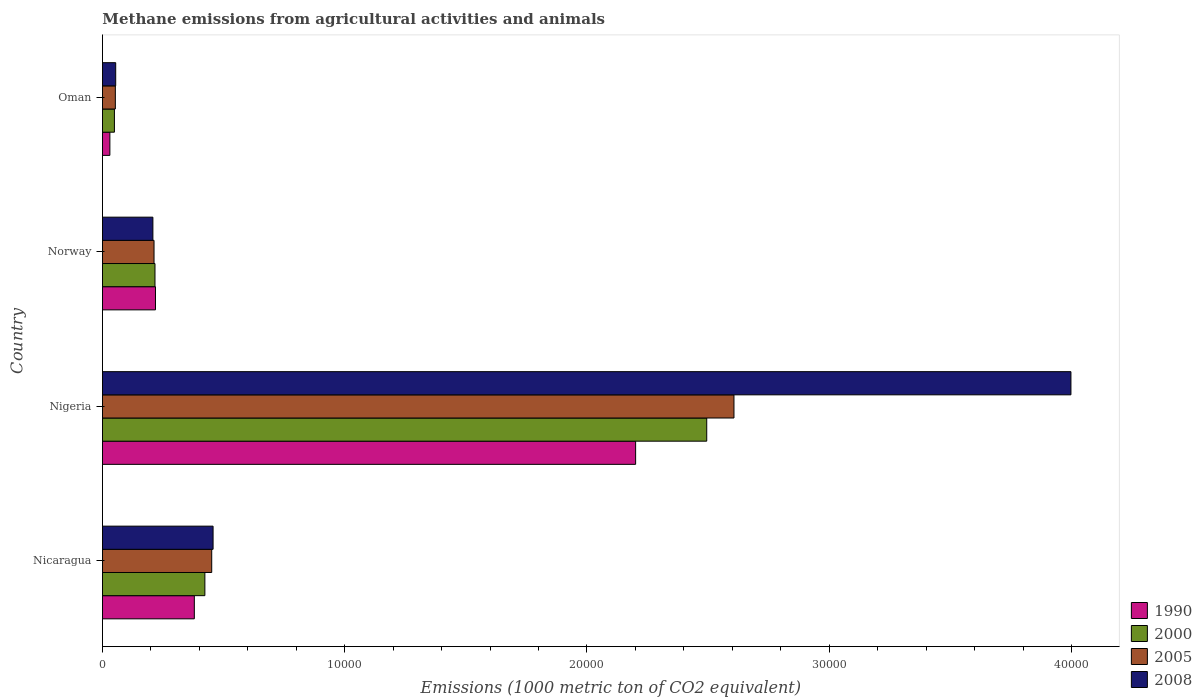Are the number of bars on each tick of the Y-axis equal?
Your answer should be compact. Yes. What is the amount of methane emitted in 2008 in Norway?
Keep it short and to the point. 2081.3. Across all countries, what is the maximum amount of methane emitted in 1990?
Give a very brief answer. 2.20e+04. Across all countries, what is the minimum amount of methane emitted in 2005?
Your answer should be very brief. 531.8. In which country was the amount of methane emitted in 1990 maximum?
Keep it short and to the point. Nigeria. In which country was the amount of methane emitted in 2005 minimum?
Offer a very short reply. Oman. What is the total amount of methane emitted in 2000 in the graph?
Offer a terse response. 3.18e+04. What is the difference between the amount of methane emitted in 1990 in Nicaragua and that in Oman?
Offer a very short reply. 3486.2. What is the difference between the amount of methane emitted in 2005 in Nigeria and the amount of methane emitted in 2008 in Norway?
Keep it short and to the point. 2.40e+04. What is the average amount of methane emitted in 2000 per country?
Your answer should be very brief. 7957.8. What is the difference between the amount of methane emitted in 2008 and amount of methane emitted in 2000 in Oman?
Your response must be concise. 53.2. What is the ratio of the amount of methane emitted in 2000 in Nicaragua to that in Oman?
Your answer should be compact. 8.57. Is the difference between the amount of methane emitted in 2008 in Nigeria and Norway greater than the difference between the amount of methane emitted in 2000 in Nigeria and Norway?
Give a very brief answer. Yes. What is the difference between the highest and the second highest amount of methane emitted in 2000?
Your answer should be very brief. 2.07e+04. What is the difference between the highest and the lowest amount of methane emitted in 1990?
Your answer should be very brief. 2.17e+04. Is the sum of the amount of methane emitted in 2008 in Nicaragua and Oman greater than the maximum amount of methane emitted in 2005 across all countries?
Make the answer very short. No. What does the 4th bar from the top in Norway represents?
Your response must be concise. 1990. What does the 1st bar from the bottom in Nigeria represents?
Provide a short and direct response. 1990. Is it the case that in every country, the sum of the amount of methane emitted in 2000 and amount of methane emitted in 2008 is greater than the amount of methane emitted in 2005?
Give a very brief answer. Yes. How many bars are there?
Keep it short and to the point. 16. Does the graph contain any zero values?
Your answer should be very brief. No. Where does the legend appear in the graph?
Your answer should be very brief. Bottom right. How are the legend labels stacked?
Offer a terse response. Vertical. What is the title of the graph?
Keep it short and to the point. Methane emissions from agricultural activities and animals. What is the label or title of the X-axis?
Provide a short and direct response. Emissions (1000 metric ton of CO2 equivalent). What is the Emissions (1000 metric ton of CO2 equivalent) in 1990 in Nicaragua?
Your answer should be very brief. 3791.8. What is the Emissions (1000 metric ton of CO2 equivalent) in 2000 in Nicaragua?
Offer a terse response. 4227.1. What is the Emissions (1000 metric ton of CO2 equivalent) of 2005 in Nicaragua?
Your answer should be very brief. 4510. What is the Emissions (1000 metric ton of CO2 equivalent) in 2008 in Nicaragua?
Your answer should be compact. 4565.5. What is the Emissions (1000 metric ton of CO2 equivalent) in 1990 in Nigeria?
Provide a short and direct response. 2.20e+04. What is the Emissions (1000 metric ton of CO2 equivalent) in 2000 in Nigeria?
Give a very brief answer. 2.49e+04. What is the Emissions (1000 metric ton of CO2 equivalent) of 2005 in Nigeria?
Provide a succinct answer. 2.61e+04. What is the Emissions (1000 metric ton of CO2 equivalent) of 2008 in Nigeria?
Keep it short and to the point. 4.00e+04. What is the Emissions (1000 metric ton of CO2 equivalent) in 1990 in Norway?
Offer a very short reply. 2188.5. What is the Emissions (1000 metric ton of CO2 equivalent) of 2000 in Norway?
Your answer should be very brief. 2167.9. What is the Emissions (1000 metric ton of CO2 equivalent) in 2005 in Norway?
Offer a very short reply. 2128.6. What is the Emissions (1000 metric ton of CO2 equivalent) of 2008 in Norway?
Your answer should be very brief. 2081.3. What is the Emissions (1000 metric ton of CO2 equivalent) in 1990 in Oman?
Keep it short and to the point. 305.6. What is the Emissions (1000 metric ton of CO2 equivalent) in 2000 in Oman?
Provide a short and direct response. 493.2. What is the Emissions (1000 metric ton of CO2 equivalent) of 2005 in Oman?
Your response must be concise. 531.8. What is the Emissions (1000 metric ton of CO2 equivalent) of 2008 in Oman?
Give a very brief answer. 546.4. Across all countries, what is the maximum Emissions (1000 metric ton of CO2 equivalent) of 1990?
Keep it short and to the point. 2.20e+04. Across all countries, what is the maximum Emissions (1000 metric ton of CO2 equivalent) of 2000?
Provide a short and direct response. 2.49e+04. Across all countries, what is the maximum Emissions (1000 metric ton of CO2 equivalent) in 2005?
Your answer should be very brief. 2.61e+04. Across all countries, what is the maximum Emissions (1000 metric ton of CO2 equivalent) in 2008?
Keep it short and to the point. 4.00e+04. Across all countries, what is the minimum Emissions (1000 metric ton of CO2 equivalent) in 1990?
Provide a short and direct response. 305.6. Across all countries, what is the minimum Emissions (1000 metric ton of CO2 equivalent) of 2000?
Your answer should be very brief. 493.2. Across all countries, what is the minimum Emissions (1000 metric ton of CO2 equivalent) of 2005?
Offer a very short reply. 531.8. Across all countries, what is the minimum Emissions (1000 metric ton of CO2 equivalent) of 2008?
Provide a short and direct response. 546.4. What is the total Emissions (1000 metric ton of CO2 equivalent) of 1990 in the graph?
Your response must be concise. 2.83e+04. What is the total Emissions (1000 metric ton of CO2 equivalent) in 2000 in the graph?
Provide a succinct answer. 3.18e+04. What is the total Emissions (1000 metric ton of CO2 equivalent) in 2005 in the graph?
Offer a very short reply. 3.32e+04. What is the total Emissions (1000 metric ton of CO2 equivalent) of 2008 in the graph?
Your answer should be very brief. 4.72e+04. What is the difference between the Emissions (1000 metric ton of CO2 equivalent) of 1990 in Nicaragua and that in Nigeria?
Ensure brevity in your answer.  -1.82e+04. What is the difference between the Emissions (1000 metric ton of CO2 equivalent) in 2000 in Nicaragua and that in Nigeria?
Offer a terse response. -2.07e+04. What is the difference between the Emissions (1000 metric ton of CO2 equivalent) in 2005 in Nicaragua and that in Nigeria?
Ensure brevity in your answer.  -2.16e+04. What is the difference between the Emissions (1000 metric ton of CO2 equivalent) in 2008 in Nicaragua and that in Nigeria?
Your answer should be compact. -3.54e+04. What is the difference between the Emissions (1000 metric ton of CO2 equivalent) in 1990 in Nicaragua and that in Norway?
Your response must be concise. 1603.3. What is the difference between the Emissions (1000 metric ton of CO2 equivalent) in 2000 in Nicaragua and that in Norway?
Offer a very short reply. 2059.2. What is the difference between the Emissions (1000 metric ton of CO2 equivalent) in 2005 in Nicaragua and that in Norway?
Your answer should be compact. 2381.4. What is the difference between the Emissions (1000 metric ton of CO2 equivalent) in 2008 in Nicaragua and that in Norway?
Your answer should be compact. 2484.2. What is the difference between the Emissions (1000 metric ton of CO2 equivalent) in 1990 in Nicaragua and that in Oman?
Make the answer very short. 3486.2. What is the difference between the Emissions (1000 metric ton of CO2 equivalent) in 2000 in Nicaragua and that in Oman?
Make the answer very short. 3733.9. What is the difference between the Emissions (1000 metric ton of CO2 equivalent) in 2005 in Nicaragua and that in Oman?
Ensure brevity in your answer.  3978.2. What is the difference between the Emissions (1000 metric ton of CO2 equivalent) of 2008 in Nicaragua and that in Oman?
Offer a terse response. 4019.1. What is the difference between the Emissions (1000 metric ton of CO2 equivalent) in 1990 in Nigeria and that in Norway?
Offer a terse response. 1.98e+04. What is the difference between the Emissions (1000 metric ton of CO2 equivalent) in 2000 in Nigeria and that in Norway?
Offer a very short reply. 2.28e+04. What is the difference between the Emissions (1000 metric ton of CO2 equivalent) in 2005 in Nigeria and that in Norway?
Your response must be concise. 2.39e+04. What is the difference between the Emissions (1000 metric ton of CO2 equivalent) in 2008 in Nigeria and that in Norway?
Provide a short and direct response. 3.79e+04. What is the difference between the Emissions (1000 metric ton of CO2 equivalent) in 1990 in Nigeria and that in Oman?
Ensure brevity in your answer.  2.17e+04. What is the difference between the Emissions (1000 metric ton of CO2 equivalent) in 2000 in Nigeria and that in Oman?
Give a very brief answer. 2.44e+04. What is the difference between the Emissions (1000 metric ton of CO2 equivalent) in 2005 in Nigeria and that in Oman?
Offer a very short reply. 2.55e+04. What is the difference between the Emissions (1000 metric ton of CO2 equivalent) in 2008 in Nigeria and that in Oman?
Make the answer very short. 3.94e+04. What is the difference between the Emissions (1000 metric ton of CO2 equivalent) in 1990 in Norway and that in Oman?
Provide a short and direct response. 1882.9. What is the difference between the Emissions (1000 metric ton of CO2 equivalent) in 2000 in Norway and that in Oman?
Give a very brief answer. 1674.7. What is the difference between the Emissions (1000 metric ton of CO2 equivalent) in 2005 in Norway and that in Oman?
Your response must be concise. 1596.8. What is the difference between the Emissions (1000 metric ton of CO2 equivalent) in 2008 in Norway and that in Oman?
Make the answer very short. 1534.9. What is the difference between the Emissions (1000 metric ton of CO2 equivalent) in 1990 in Nicaragua and the Emissions (1000 metric ton of CO2 equivalent) in 2000 in Nigeria?
Your response must be concise. -2.12e+04. What is the difference between the Emissions (1000 metric ton of CO2 equivalent) in 1990 in Nicaragua and the Emissions (1000 metric ton of CO2 equivalent) in 2005 in Nigeria?
Your response must be concise. -2.23e+04. What is the difference between the Emissions (1000 metric ton of CO2 equivalent) of 1990 in Nicaragua and the Emissions (1000 metric ton of CO2 equivalent) of 2008 in Nigeria?
Offer a terse response. -3.62e+04. What is the difference between the Emissions (1000 metric ton of CO2 equivalent) of 2000 in Nicaragua and the Emissions (1000 metric ton of CO2 equivalent) of 2005 in Nigeria?
Offer a terse response. -2.18e+04. What is the difference between the Emissions (1000 metric ton of CO2 equivalent) of 2000 in Nicaragua and the Emissions (1000 metric ton of CO2 equivalent) of 2008 in Nigeria?
Offer a very short reply. -3.57e+04. What is the difference between the Emissions (1000 metric ton of CO2 equivalent) of 2005 in Nicaragua and the Emissions (1000 metric ton of CO2 equivalent) of 2008 in Nigeria?
Keep it short and to the point. -3.55e+04. What is the difference between the Emissions (1000 metric ton of CO2 equivalent) of 1990 in Nicaragua and the Emissions (1000 metric ton of CO2 equivalent) of 2000 in Norway?
Keep it short and to the point. 1623.9. What is the difference between the Emissions (1000 metric ton of CO2 equivalent) in 1990 in Nicaragua and the Emissions (1000 metric ton of CO2 equivalent) in 2005 in Norway?
Keep it short and to the point. 1663.2. What is the difference between the Emissions (1000 metric ton of CO2 equivalent) of 1990 in Nicaragua and the Emissions (1000 metric ton of CO2 equivalent) of 2008 in Norway?
Offer a very short reply. 1710.5. What is the difference between the Emissions (1000 metric ton of CO2 equivalent) of 2000 in Nicaragua and the Emissions (1000 metric ton of CO2 equivalent) of 2005 in Norway?
Provide a succinct answer. 2098.5. What is the difference between the Emissions (1000 metric ton of CO2 equivalent) in 2000 in Nicaragua and the Emissions (1000 metric ton of CO2 equivalent) in 2008 in Norway?
Ensure brevity in your answer.  2145.8. What is the difference between the Emissions (1000 metric ton of CO2 equivalent) in 2005 in Nicaragua and the Emissions (1000 metric ton of CO2 equivalent) in 2008 in Norway?
Make the answer very short. 2428.7. What is the difference between the Emissions (1000 metric ton of CO2 equivalent) of 1990 in Nicaragua and the Emissions (1000 metric ton of CO2 equivalent) of 2000 in Oman?
Your answer should be very brief. 3298.6. What is the difference between the Emissions (1000 metric ton of CO2 equivalent) in 1990 in Nicaragua and the Emissions (1000 metric ton of CO2 equivalent) in 2005 in Oman?
Ensure brevity in your answer.  3260. What is the difference between the Emissions (1000 metric ton of CO2 equivalent) in 1990 in Nicaragua and the Emissions (1000 metric ton of CO2 equivalent) in 2008 in Oman?
Offer a terse response. 3245.4. What is the difference between the Emissions (1000 metric ton of CO2 equivalent) in 2000 in Nicaragua and the Emissions (1000 metric ton of CO2 equivalent) in 2005 in Oman?
Provide a succinct answer. 3695.3. What is the difference between the Emissions (1000 metric ton of CO2 equivalent) in 2000 in Nicaragua and the Emissions (1000 metric ton of CO2 equivalent) in 2008 in Oman?
Your answer should be very brief. 3680.7. What is the difference between the Emissions (1000 metric ton of CO2 equivalent) in 2005 in Nicaragua and the Emissions (1000 metric ton of CO2 equivalent) in 2008 in Oman?
Ensure brevity in your answer.  3963.6. What is the difference between the Emissions (1000 metric ton of CO2 equivalent) of 1990 in Nigeria and the Emissions (1000 metric ton of CO2 equivalent) of 2000 in Norway?
Ensure brevity in your answer.  1.98e+04. What is the difference between the Emissions (1000 metric ton of CO2 equivalent) in 1990 in Nigeria and the Emissions (1000 metric ton of CO2 equivalent) in 2005 in Norway?
Offer a very short reply. 1.99e+04. What is the difference between the Emissions (1000 metric ton of CO2 equivalent) in 1990 in Nigeria and the Emissions (1000 metric ton of CO2 equivalent) in 2008 in Norway?
Keep it short and to the point. 1.99e+04. What is the difference between the Emissions (1000 metric ton of CO2 equivalent) in 2000 in Nigeria and the Emissions (1000 metric ton of CO2 equivalent) in 2005 in Norway?
Offer a terse response. 2.28e+04. What is the difference between the Emissions (1000 metric ton of CO2 equivalent) in 2000 in Nigeria and the Emissions (1000 metric ton of CO2 equivalent) in 2008 in Norway?
Your answer should be very brief. 2.29e+04. What is the difference between the Emissions (1000 metric ton of CO2 equivalent) in 2005 in Nigeria and the Emissions (1000 metric ton of CO2 equivalent) in 2008 in Norway?
Your answer should be compact. 2.40e+04. What is the difference between the Emissions (1000 metric ton of CO2 equivalent) in 1990 in Nigeria and the Emissions (1000 metric ton of CO2 equivalent) in 2000 in Oman?
Offer a very short reply. 2.15e+04. What is the difference between the Emissions (1000 metric ton of CO2 equivalent) in 1990 in Nigeria and the Emissions (1000 metric ton of CO2 equivalent) in 2005 in Oman?
Keep it short and to the point. 2.15e+04. What is the difference between the Emissions (1000 metric ton of CO2 equivalent) in 1990 in Nigeria and the Emissions (1000 metric ton of CO2 equivalent) in 2008 in Oman?
Your answer should be very brief. 2.15e+04. What is the difference between the Emissions (1000 metric ton of CO2 equivalent) in 2000 in Nigeria and the Emissions (1000 metric ton of CO2 equivalent) in 2005 in Oman?
Give a very brief answer. 2.44e+04. What is the difference between the Emissions (1000 metric ton of CO2 equivalent) in 2000 in Nigeria and the Emissions (1000 metric ton of CO2 equivalent) in 2008 in Oman?
Ensure brevity in your answer.  2.44e+04. What is the difference between the Emissions (1000 metric ton of CO2 equivalent) of 2005 in Nigeria and the Emissions (1000 metric ton of CO2 equivalent) of 2008 in Oman?
Keep it short and to the point. 2.55e+04. What is the difference between the Emissions (1000 metric ton of CO2 equivalent) in 1990 in Norway and the Emissions (1000 metric ton of CO2 equivalent) in 2000 in Oman?
Keep it short and to the point. 1695.3. What is the difference between the Emissions (1000 metric ton of CO2 equivalent) of 1990 in Norway and the Emissions (1000 metric ton of CO2 equivalent) of 2005 in Oman?
Your response must be concise. 1656.7. What is the difference between the Emissions (1000 metric ton of CO2 equivalent) in 1990 in Norway and the Emissions (1000 metric ton of CO2 equivalent) in 2008 in Oman?
Your answer should be compact. 1642.1. What is the difference between the Emissions (1000 metric ton of CO2 equivalent) of 2000 in Norway and the Emissions (1000 metric ton of CO2 equivalent) of 2005 in Oman?
Your response must be concise. 1636.1. What is the difference between the Emissions (1000 metric ton of CO2 equivalent) of 2000 in Norway and the Emissions (1000 metric ton of CO2 equivalent) of 2008 in Oman?
Keep it short and to the point. 1621.5. What is the difference between the Emissions (1000 metric ton of CO2 equivalent) in 2005 in Norway and the Emissions (1000 metric ton of CO2 equivalent) in 2008 in Oman?
Your answer should be very brief. 1582.2. What is the average Emissions (1000 metric ton of CO2 equivalent) in 1990 per country?
Your answer should be very brief. 7073.32. What is the average Emissions (1000 metric ton of CO2 equivalent) in 2000 per country?
Offer a terse response. 7957.8. What is the average Emissions (1000 metric ton of CO2 equivalent) in 2005 per country?
Provide a succinct answer. 8309.3. What is the average Emissions (1000 metric ton of CO2 equivalent) of 2008 per country?
Your answer should be compact. 1.18e+04. What is the difference between the Emissions (1000 metric ton of CO2 equivalent) in 1990 and Emissions (1000 metric ton of CO2 equivalent) in 2000 in Nicaragua?
Make the answer very short. -435.3. What is the difference between the Emissions (1000 metric ton of CO2 equivalent) of 1990 and Emissions (1000 metric ton of CO2 equivalent) of 2005 in Nicaragua?
Keep it short and to the point. -718.2. What is the difference between the Emissions (1000 metric ton of CO2 equivalent) of 1990 and Emissions (1000 metric ton of CO2 equivalent) of 2008 in Nicaragua?
Offer a terse response. -773.7. What is the difference between the Emissions (1000 metric ton of CO2 equivalent) of 2000 and Emissions (1000 metric ton of CO2 equivalent) of 2005 in Nicaragua?
Make the answer very short. -282.9. What is the difference between the Emissions (1000 metric ton of CO2 equivalent) in 2000 and Emissions (1000 metric ton of CO2 equivalent) in 2008 in Nicaragua?
Provide a short and direct response. -338.4. What is the difference between the Emissions (1000 metric ton of CO2 equivalent) of 2005 and Emissions (1000 metric ton of CO2 equivalent) of 2008 in Nicaragua?
Provide a short and direct response. -55.5. What is the difference between the Emissions (1000 metric ton of CO2 equivalent) in 1990 and Emissions (1000 metric ton of CO2 equivalent) in 2000 in Nigeria?
Give a very brief answer. -2935.6. What is the difference between the Emissions (1000 metric ton of CO2 equivalent) of 1990 and Emissions (1000 metric ton of CO2 equivalent) of 2005 in Nigeria?
Give a very brief answer. -4059.4. What is the difference between the Emissions (1000 metric ton of CO2 equivalent) in 1990 and Emissions (1000 metric ton of CO2 equivalent) in 2008 in Nigeria?
Keep it short and to the point. -1.80e+04. What is the difference between the Emissions (1000 metric ton of CO2 equivalent) of 2000 and Emissions (1000 metric ton of CO2 equivalent) of 2005 in Nigeria?
Make the answer very short. -1123.8. What is the difference between the Emissions (1000 metric ton of CO2 equivalent) in 2000 and Emissions (1000 metric ton of CO2 equivalent) in 2008 in Nigeria?
Make the answer very short. -1.50e+04. What is the difference between the Emissions (1000 metric ton of CO2 equivalent) of 2005 and Emissions (1000 metric ton of CO2 equivalent) of 2008 in Nigeria?
Provide a succinct answer. -1.39e+04. What is the difference between the Emissions (1000 metric ton of CO2 equivalent) in 1990 and Emissions (1000 metric ton of CO2 equivalent) in 2000 in Norway?
Your answer should be compact. 20.6. What is the difference between the Emissions (1000 metric ton of CO2 equivalent) in 1990 and Emissions (1000 metric ton of CO2 equivalent) in 2005 in Norway?
Your answer should be very brief. 59.9. What is the difference between the Emissions (1000 metric ton of CO2 equivalent) in 1990 and Emissions (1000 metric ton of CO2 equivalent) in 2008 in Norway?
Your response must be concise. 107.2. What is the difference between the Emissions (1000 metric ton of CO2 equivalent) in 2000 and Emissions (1000 metric ton of CO2 equivalent) in 2005 in Norway?
Make the answer very short. 39.3. What is the difference between the Emissions (1000 metric ton of CO2 equivalent) in 2000 and Emissions (1000 metric ton of CO2 equivalent) in 2008 in Norway?
Your answer should be very brief. 86.6. What is the difference between the Emissions (1000 metric ton of CO2 equivalent) of 2005 and Emissions (1000 metric ton of CO2 equivalent) of 2008 in Norway?
Your response must be concise. 47.3. What is the difference between the Emissions (1000 metric ton of CO2 equivalent) in 1990 and Emissions (1000 metric ton of CO2 equivalent) in 2000 in Oman?
Offer a very short reply. -187.6. What is the difference between the Emissions (1000 metric ton of CO2 equivalent) in 1990 and Emissions (1000 metric ton of CO2 equivalent) in 2005 in Oman?
Your response must be concise. -226.2. What is the difference between the Emissions (1000 metric ton of CO2 equivalent) in 1990 and Emissions (1000 metric ton of CO2 equivalent) in 2008 in Oman?
Provide a short and direct response. -240.8. What is the difference between the Emissions (1000 metric ton of CO2 equivalent) in 2000 and Emissions (1000 metric ton of CO2 equivalent) in 2005 in Oman?
Your answer should be very brief. -38.6. What is the difference between the Emissions (1000 metric ton of CO2 equivalent) in 2000 and Emissions (1000 metric ton of CO2 equivalent) in 2008 in Oman?
Give a very brief answer. -53.2. What is the difference between the Emissions (1000 metric ton of CO2 equivalent) of 2005 and Emissions (1000 metric ton of CO2 equivalent) of 2008 in Oman?
Provide a succinct answer. -14.6. What is the ratio of the Emissions (1000 metric ton of CO2 equivalent) in 1990 in Nicaragua to that in Nigeria?
Provide a succinct answer. 0.17. What is the ratio of the Emissions (1000 metric ton of CO2 equivalent) of 2000 in Nicaragua to that in Nigeria?
Provide a short and direct response. 0.17. What is the ratio of the Emissions (1000 metric ton of CO2 equivalent) of 2005 in Nicaragua to that in Nigeria?
Keep it short and to the point. 0.17. What is the ratio of the Emissions (1000 metric ton of CO2 equivalent) in 2008 in Nicaragua to that in Nigeria?
Ensure brevity in your answer.  0.11. What is the ratio of the Emissions (1000 metric ton of CO2 equivalent) of 1990 in Nicaragua to that in Norway?
Offer a terse response. 1.73. What is the ratio of the Emissions (1000 metric ton of CO2 equivalent) in 2000 in Nicaragua to that in Norway?
Ensure brevity in your answer.  1.95. What is the ratio of the Emissions (1000 metric ton of CO2 equivalent) in 2005 in Nicaragua to that in Norway?
Ensure brevity in your answer.  2.12. What is the ratio of the Emissions (1000 metric ton of CO2 equivalent) in 2008 in Nicaragua to that in Norway?
Ensure brevity in your answer.  2.19. What is the ratio of the Emissions (1000 metric ton of CO2 equivalent) in 1990 in Nicaragua to that in Oman?
Offer a terse response. 12.41. What is the ratio of the Emissions (1000 metric ton of CO2 equivalent) in 2000 in Nicaragua to that in Oman?
Provide a short and direct response. 8.57. What is the ratio of the Emissions (1000 metric ton of CO2 equivalent) of 2005 in Nicaragua to that in Oman?
Offer a terse response. 8.48. What is the ratio of the Emissions (1000 metric ton of CO2 equivalent) of 2008 in Nicaragua to that in Oman?
Provide a short and direct response. 8.36. What is the ratio of the Emissions (1000 metric ton of CO2 equivalent) in 1990 in Nigeria to that in Norway?
Keep it short and to the point. 10.06. What is the ratio of the Emissions (1000 metric ton of CO2 equivalent) of 2000 in Nigeria to that in Norway?
Offer a very short reply. 11.51. What is the ratio of the Emissions (1000 metric ton of CO2 equivalent) of 2005 in Nigeria to that in Norway?
Your answer should be compact. 12.25. What is the ratio of the Emissions (1000 metric ton of CO2 equivalent) of 2008 in Nigeria to that in Norway?
Provide a succinct answer. 19.21. What is the ratio of the Emissions (1000 metric ton of CO2 equivalent) of 1990 in Nigeria to that in Oman?
Your answer should be compact. 72.01. What is the ratio of the Emissions (1000 metric ton of CO2 equivalent) in 2000 in Nigeria to that in Oman?
Your response must be concise. 50.57. What is the ratio of the Emissions (1000 metric ton of CO2 equivalent) of 2005 in Nigeria to that in Oman?
Your response must be concise. 49.02. What is the ratio of the Emissions (1000 metric ton of CO2 equivalent) in 2008 in Nigeria to that in Oman?
Your answer should be very brief. 73.16. What is the ratio of the Emissions (1000 metric ton of CO2 equivalent) in 1990 in Norway to that in Oman?
Make the answer very short. 7.16. What is the ratio of the Emissions (1000 metric ton of CO2 equivalent) of 2000 in Norway to that in Oman?
Offer a very short reply. 4.4. What is the ratio of the Emissions (1000 metric ton of CO2 equivalent) of 2005 in Norway to that in Oman?
Offer a very short reply. 4. What is the ratio of the Emissions (1000 metric ton of CO2 equivalent) in 2008 in Norway to that in Oman?
Offer a terse response. 3.81. What is the difference between the highest and the second highest Emissions (1000 metric ton of CO2 equivalent) of 1990?
Give a very brief answer. 1.82e+04. What is the difference between the highest and the second highest Emissions (1000 metric ton of CO2 equivalent) of 2000?
Your answer should be compact. 2.07e+04. What is the difference between the highest and the second highest Emissions (1000 metric ton of CO2 equivalent) in 2005?
Make the answer very short. 2.16e+04. What is the difference between the highest and the second highest Emissions (1000 metric ton of CO2 equivalent) of 2008?
Keep it short and to the point. 3.54e+04. What is the difference between the highest and the lowest Emissions (1000 metric ton of CO2 equivalent) in 1990?
Your response must be concise. 2.17e+04. What is the difference between the highest and the lowest Emissions (1000 metric ton of CO2 equivalent) of 2000?
Your response must be concise. 2.44e+04. What is the difference between the highest and the lowest Emissions (1000 metric ton of CO2 equivalent) in 2005?
Your answer should be compact. 2.55e+04. What is the difference between the highest and the lowest Emissions (1000 metric ton of CO2 equivalent) of 2008?
Provide a short and direct response. 3.94e+04. 